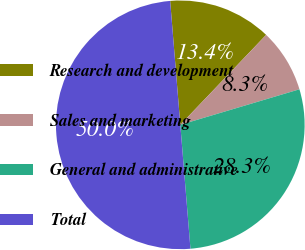Convert chart. <chart><loc_0><loc_0><loc_500><loc_500><pie_chart><fcel>Research and development<fcel>Sales and marketing<fcel>General and administrative<fcel>Total<nl><fcel>13.43%<fcel>8.26%<fcel>28.31%<fcel>50.0%<nl></chart> 